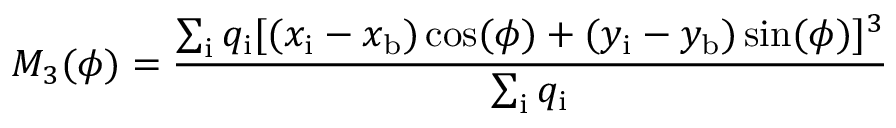<formula> <loc_0><loc_0><loc_500><loc_500>M _ { 3 } ( \phi ) = \frac { \sum _ { i } q _ { i } [ ( x _ { i } - x _ { b } ) \cos ( \phi ) + ( y _ { i } - y _ { b } ) \sin ( \phi ) ] ^ { 3 } } { \sum _ { i } q _ { i } }</formula> 